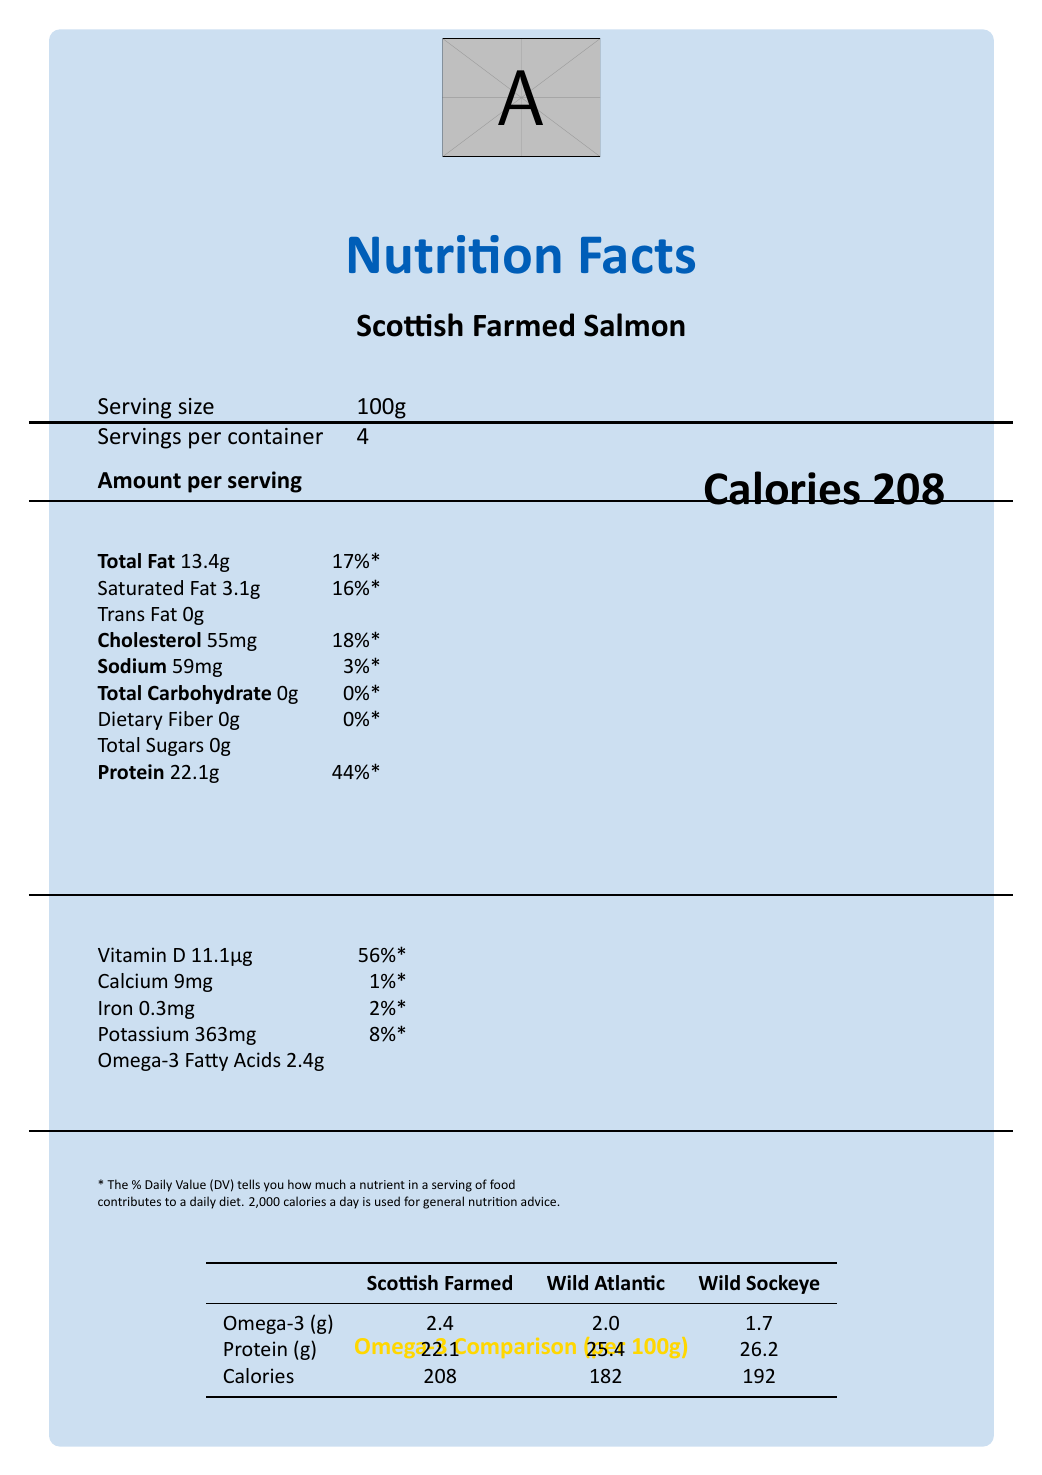what is the serving size of Scottish Farmed Salmon? The serving size is explicitly mentioned in the section "Serving size" of the document.
Answer: 100g how many calories are there per serving of Scottish Farmed Salmon? The calorie count per serving is clearly stated next to "Calories".
Answer: 208 what is the amount of Omega-3 fatty acids in Scottish Farmed Salmon compared to Wild Atlantic Salmon? This information is provided in the Omega-3 Comparison table at the bottom of the document.
Answer: 2.4g in Scottish Farmed Salmon and 2.0g in Wild Atlantic Salmon what is the sustainability rating of Scottish Farmed Salmon? The sustainability rating is mentioned in the additional information section under "sustainability rating".
Answer: ASC certified what is the economic impact of the Scottish Farmed Salmon industry? This information is detailed in the additional information section under "economic impact".
Answer: Contributes £2 billion annually to Scottish economy which type of salmon has the highest protein content per 100g? A. Scottish Farmed Salmon B. Wild Atlantic Salmon C. Wild Sockeye Salmon According to the Omega-3 Comparison table, Wild Sockeye Salmon has the highest protein content with 26.2g.
Answer: C how many servings per container does Scottish Farmed Salmon have? This is stated under the section "Servings per container".
Answer: 4 how much Vitamin D does Scottish Farmed Salmon provide per serving? This is listed under the nutritional facts for vitamins and minerals.
Answer: 11.1µg is Scottish Farmed Salmon free from trans fat? The document lists trans fat as 0g, indicating it is free from trans fat.
Answer: Yes what nutrients are Scottish Farmed Salmon low in? The document shows that these nutrients are 0g per serving.
Answer: Total Carbohydrate, Dietary Fiber, Total Sugars summarize the main nutritional differences between Scottish Farmed Salmon and wild-caught alternatives. The Omega-3 Comparison table at the bottom provides detailed comparisons showing that Scottish Farmed Salmon offers more omega-3 but less protein and more calories per serving than wild-caught alternatives.
Answer: Scottish Farmed Salmon has higher omega-3 fatty acids but lower protein content compared to Wild Atlantic and Wild Sockeye Salmon. what is the primary market for exports of Scottish Farmed Salmon? This specific piece of information is not provided in the visually presented document.
Answer: Cannot be determined where is the farming location for Scottish Farmed Salmon? This is mentioned in the additional information section under "farming location".
Answer: Loch Duart, Sutherland what is the total fat content in a 100g serving of Scottish Farmed Salmon? This value is clearly mentioned under the nutritional facts.
Answer: 13.4g which factor influences salmon farming policies in Scotland? A. Party votes B. Parliamentary debates using Additional Member System C. EU regulations D. Scottish Parliament elections The additional information section mentions that salmon farming policies are often debated in the Scottish Parliament using the Additional Member System.
Answer: B who regulates the food safety standards for Scottish Farmed Salmon? The additional information section indicates that it's subject to EU food safety standards.
Answer: EU food safety standards does Scottish Farmed Salmon contribute sodium to the diet? The document lists sodium content as 59mg per serving.
Answer: Yes what are the feed ingredients for Scottish Farmed Salmon? This information is provided under the additional information section in the feed composition part.
Answer: Marine proteins, vegetable oils, and astaxanthin 